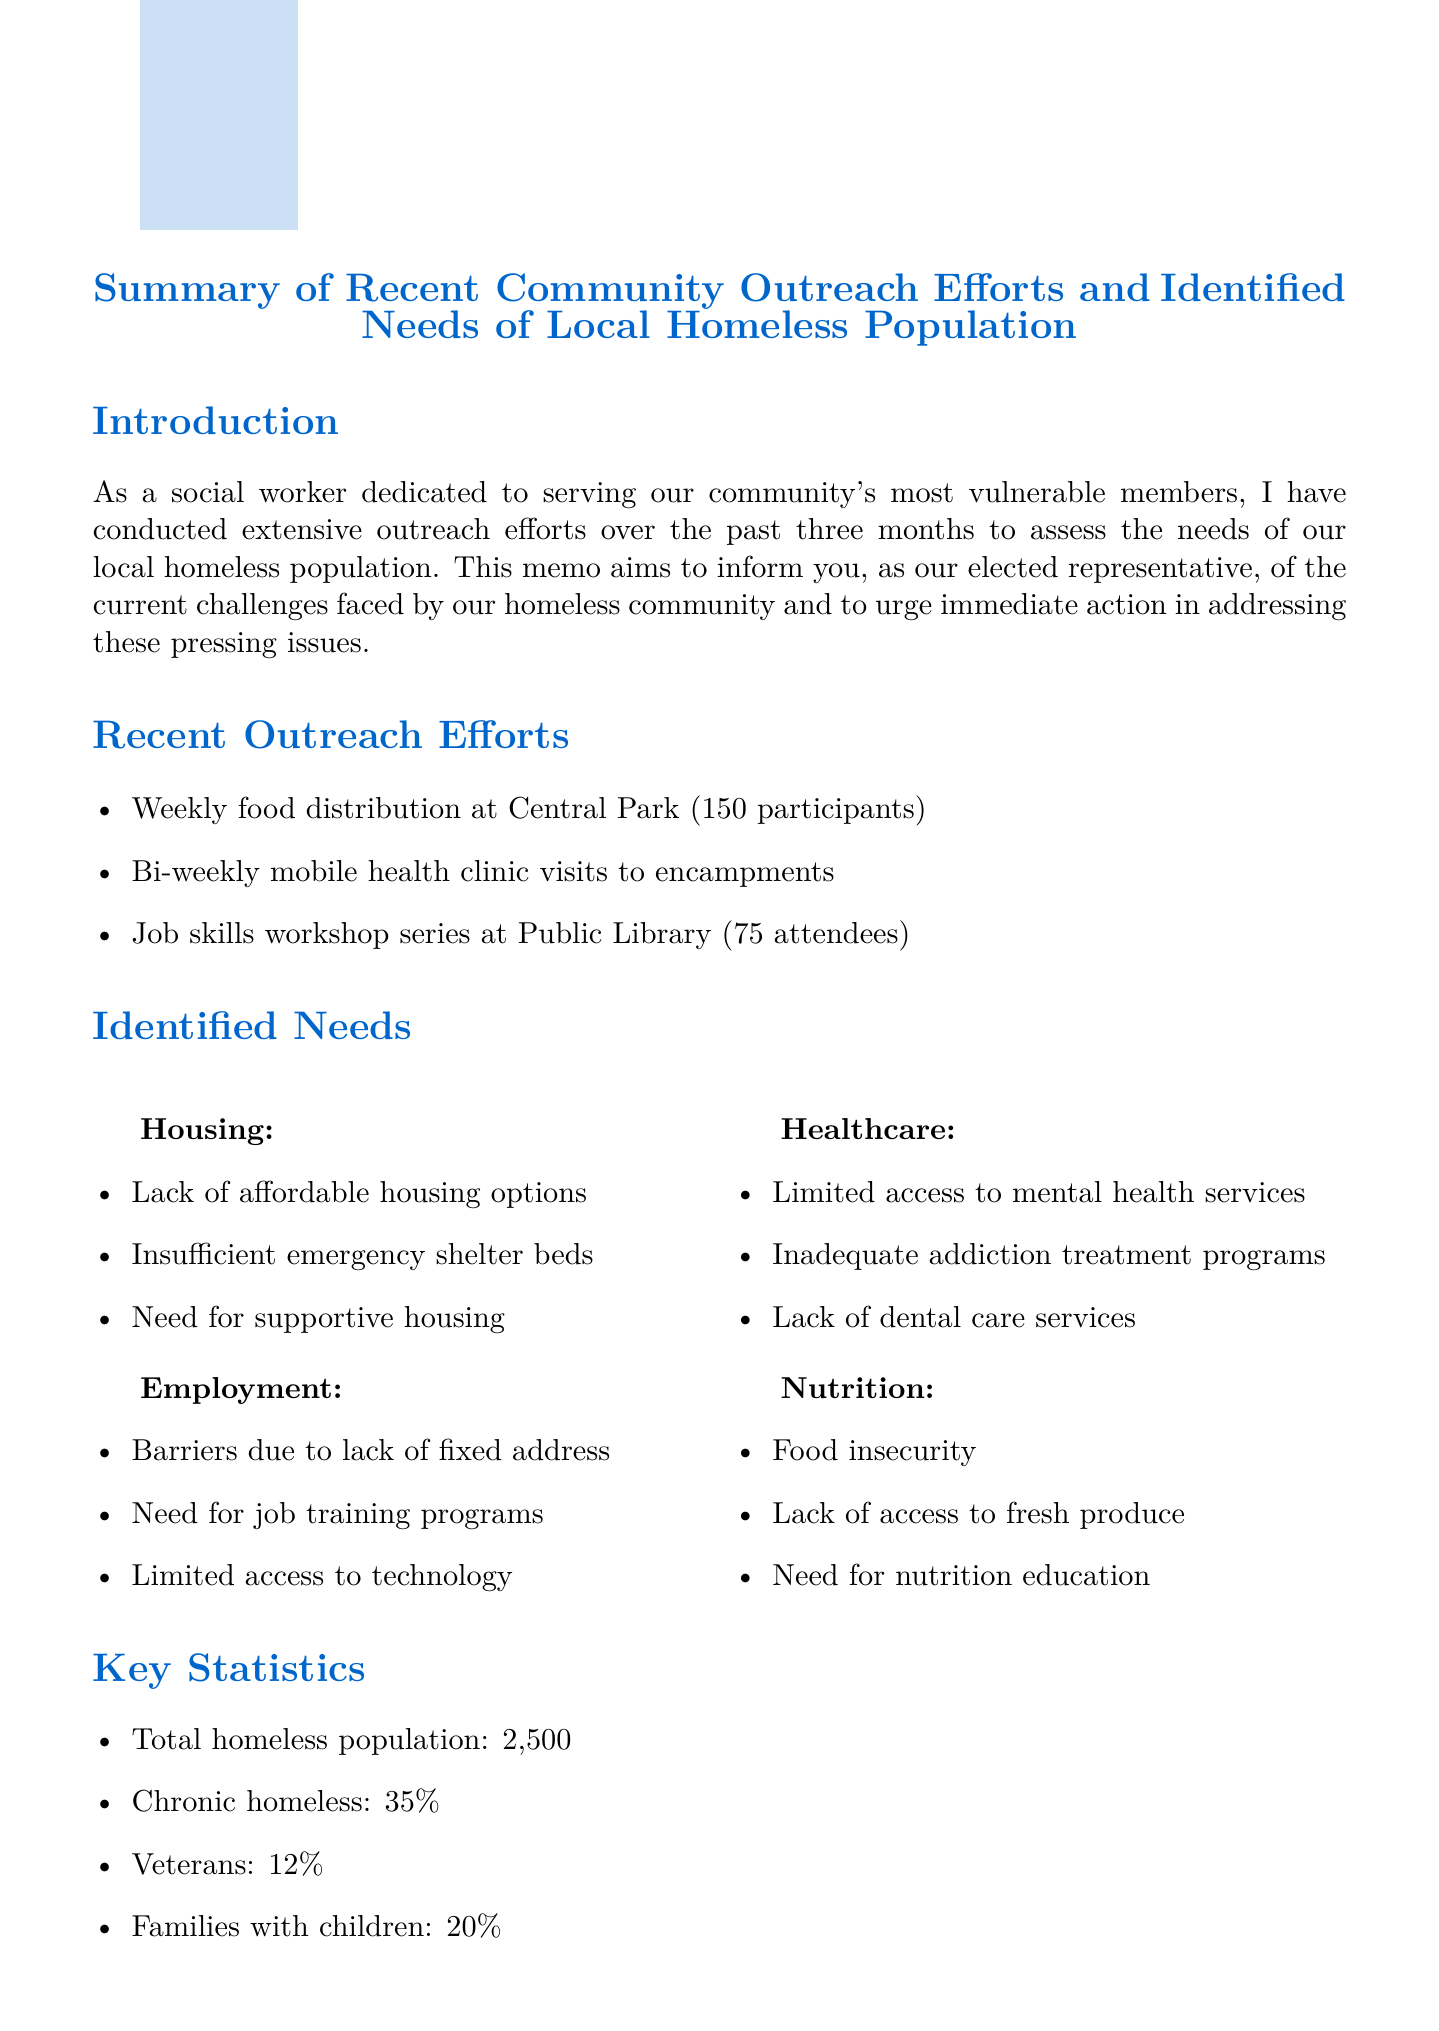What is the title of the memo? The title of the memo is stated at the beginning and summarizes its content regarding outreach and needs.
Answer: Summary of Recent Community Outreach Efforts and Identified Needs of Local Homeless Population How many participants attended the weekly food distribution? The number of participants for the weekly food distribution is provided in the outreach efforts section of the document.
Answer: 150 What percentage of the homeless population are veterans? The percentage of veterans within the homeless population is listed under key statistics.
Answer: 12 What category has issues related to food insecurity? The identified needs of the homeless population include various categories, one of which specifically addresses issues of food insecurity.
Answer: Nutrition How many additional emergency shelter beds are recommended? The urgent recommendations include a specific number of shelter beds to be allocated, as mentioned in the recommendations section.
Answer: 200 What services are provided at the mobile health clinic? The document lists specific services offered by the mobile health clinic during its visits, covering various health-related needs.
Answer: Basic health check-ups, Mental health screenings, Addiction counseling What organization partnered for the job skills workshop series? The partner organization for the job skills workshop series is mentioned in the outreach efforts related to employment training.
Answer: Department of Labor What is the total homeless population identified? The total number of individuals identified as homeless is detailed in the key statistics section of the memo.
Answer: 2500 What urgent recommendation involves mental health services? The recommendations include actions to expand specific services to address mental health needs of the homeless population.
Answer: Expand mobile mental health services to reach encampments 